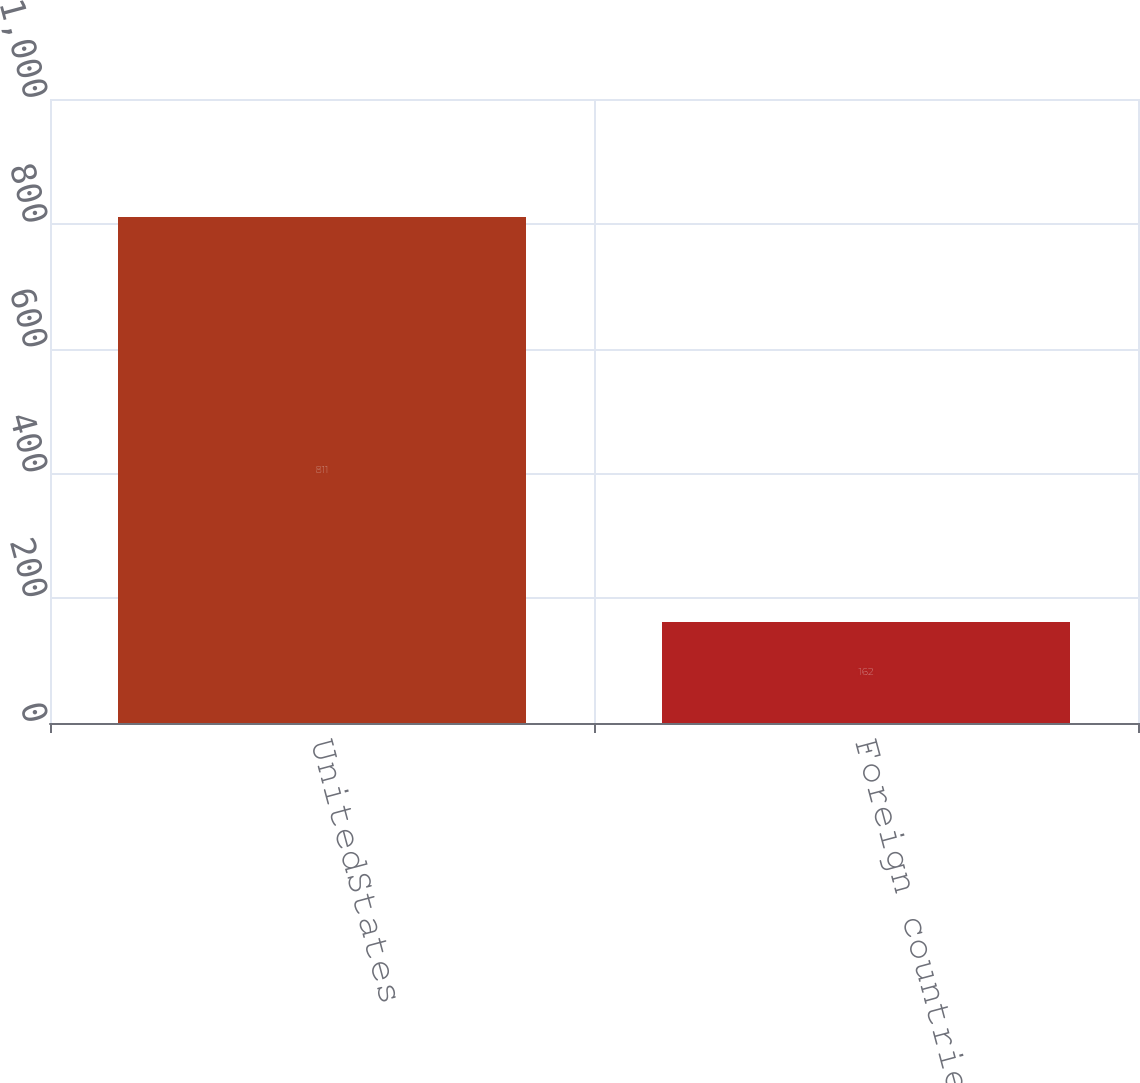<chart> <loc_0><loc_0><loc_500><loc_500><bar_chart><fcel>UnitedStates<fcel>Foreign countries (1)<nl><fcel>811<fcel>162<nl></chart> 